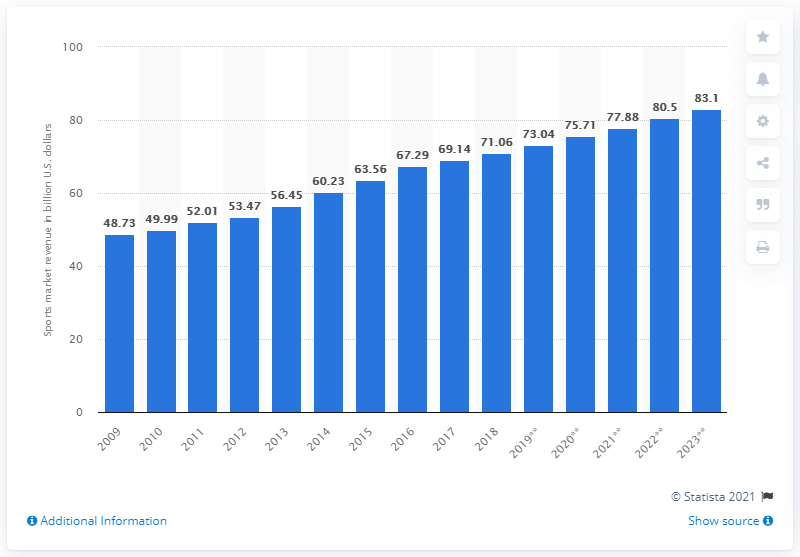Point out several critical features in this image. According to a recent report, the expected value of the North American sports market is projected to reach 83.1 billion US dollars by 2023. In 2018, the value of the North American sports market was estimated to be approximately 71.06 billion dollars. In 2018, the North American sports market came to a close. 